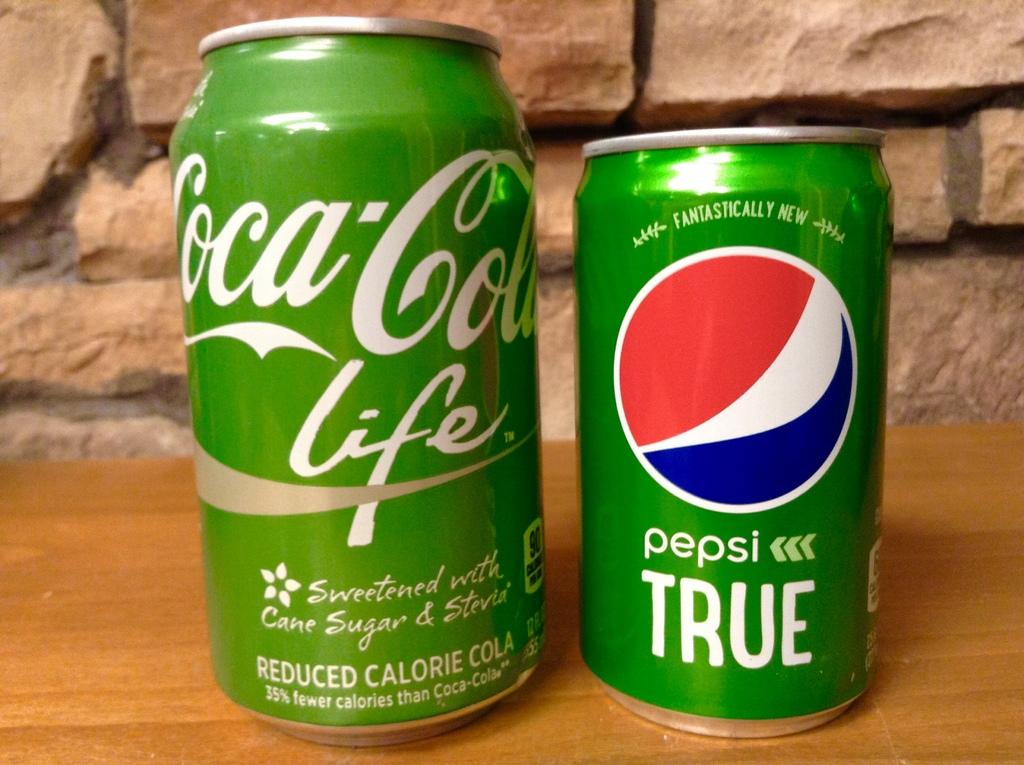<image>
Relay a brief, clear account of the picture shown. A green can of Pepsi next to a green can of Coca-Cola. 